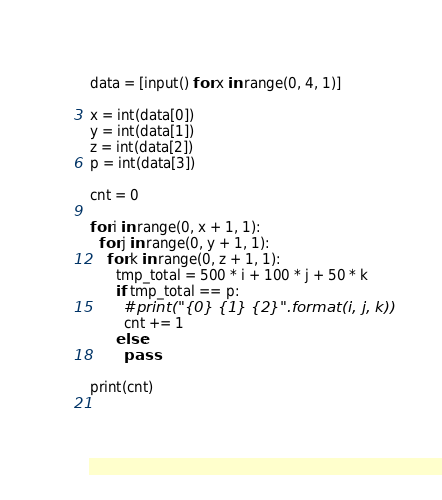Convert code to text. <code><loc_0><loc_0><loc_500><loc_500><_Python_>data = [input() for x in range(0, 4, 1)]

x = int(data[0])
y = int(data[1])
z = int(data[2])
p = int(data[3])

cnt = 0

for i in range(0, x + 1, 1):
  for j in range(0, y + 1, 1):
    for k in range(0, z + 1, 1):
      tmp_total = 500 * i + 100 * j + 50 * k
      if tmp_total == p:
        #print("{0} {1} {2}".format(i, j, k))
        cnt += 1
      else:
        pass
      
print(cnt)
  
      </code> 